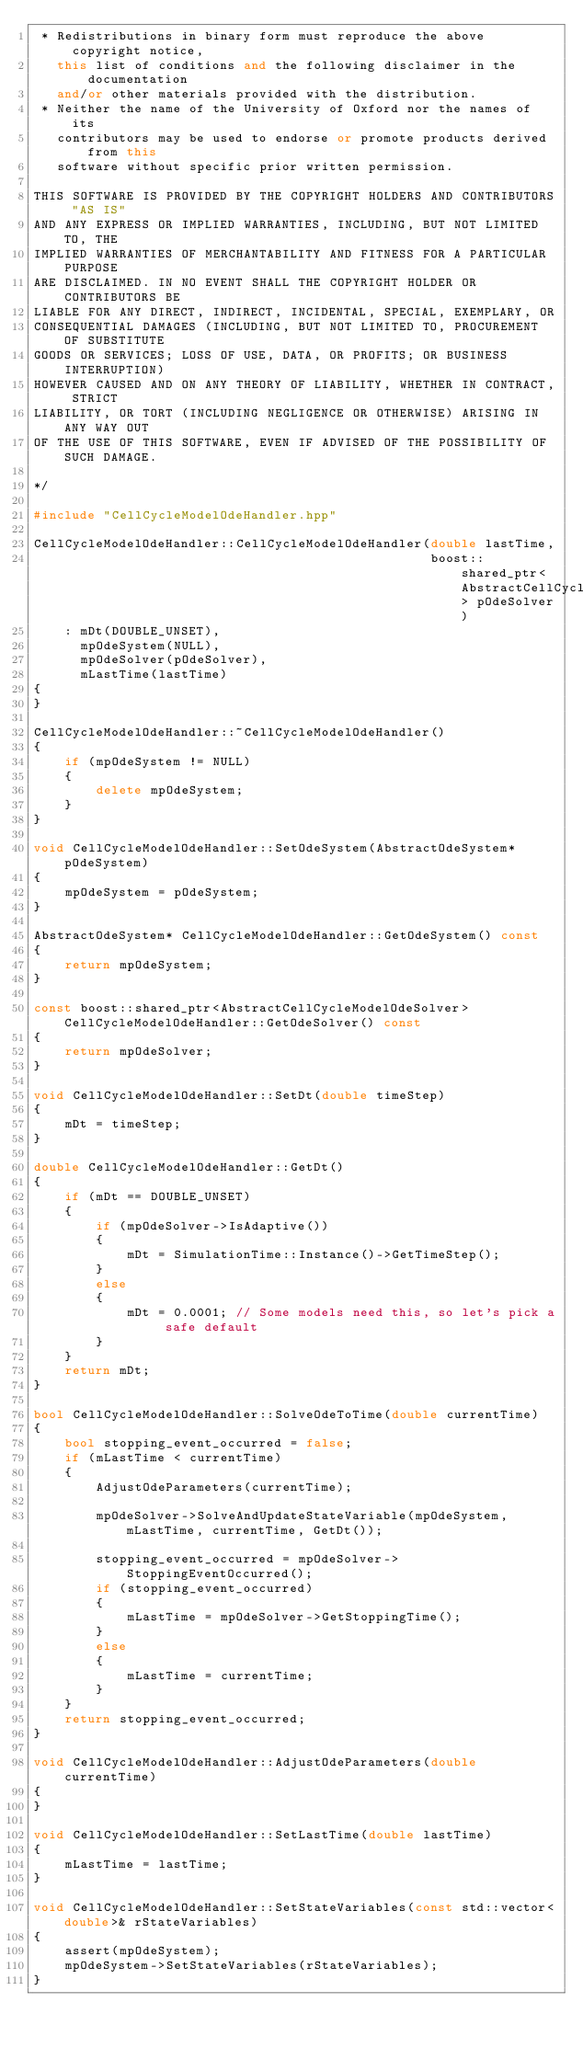<code> <loc_0><loc_0><loc_500><loc_500><_C++_> * Redistributions in binary form must reproduce the above copyright notice,
   this list of conditions and the following disclaimer in the documentation
   and/or other materials provided with the distribution.
 * Neither the name of the University of Oxford nor the names of its
   contributors may be used to endorse or promote products derived from this
   software without specific prior written permission.

THIS SOFTWARE IS PROVIDED BY THE COPYRIGHT HOLDERS AND CONTRIBUTORS "AS IS"
AND ANY EXPRESS OR IMPLIED WARRANTIES, INCLUDING, BUT NOT LIMITED TO, THE
IMPLIED WARRANTIES OF MERCHANTABILITY AND FITNESS FOR A PARTICULAR PURPOSE
ARE DISCLAIMED. IN NO EVENT SHALL THE COPYRIGHT HOLDER OR CONTRIBUTORS BE
LIABLE FOR ANY DIRECT, INDIRECT, INCIDENTAL, SPECIAL, EXEMPLARY, OR
CONSEQUENTIAL DAMAGES (INCLUDING, BUT NOT LIMITED TO, PROCUREMENT OF SUBSTITUTE
GOODS OR SERVICES; LOSS OF USE, DATA, OR PROFITS; OR BUSINESS INTERRUPTION)
HOWEVER CAUSED AND ON ANY THEORY OF LIABILITY, WHETHER IN CONTRACT, STRICT
LIABILITY, OR TORT (INCLUDING NEGLIGENCE OR OTHERWISE) ARISING IN ANY WAY OUT
OF THE USE OF THIS SOFTWARE, EVEN IF ADVISED OF THE POSSIBILITY OF SUCH DAMAGE.

*/

#include "CellCycleModelOdeHandler.hpp"

CellCycleModelOdeHandler::CellCycleModelOdeHandler(double lastTime,
                                                   boost::shared_ptr<AbstractCellCycleModelOdeSolver> pOdeSolver)
    : mDt(DOUBLE_UNSET),
      mpOdeSystem(NULL),
      mpOdeSolver(pOdeSolver),
      mLastTime(lastTime)
{
}

CellCycleModelOdeHandler::~CellCycleModelOdeHandler()
{
    if (mpOdeSystem != NULL)
    {
        delete mpOdeSystem;
    }
}

void CellCycleModelOdeHandler::SetOdeSystem(AbstractOdeSystem* pOdeSystem)
{
    mpOdeSystem = pOdeSystem;
}

AbstractOdeSystem* CellCycleModelOdeHandler::GetOdeSystem() const
{
    return mpOdeSystem;
}

const boost::shared_ptr<AbstractCellCycleModelOdeSolver> CellCycleModelOdeHandler::GetOdeSolver() const
{
    return mpOdeSolver;
}

void CellCycleModelOdeHandler::SetDt(double timeStep)
{
    mDt = timeStep;
}

double CellCycleModelOdeHandler::GetDt()
{
    if (mDt == DOUBLE_UNSET)
    {
        if (mpOdeSolver->IsAdaptive())
        {
            mDt = SimulationTime::Instance()->GetTimeStep();
        }
        else
        {
            mDt = 0.0001; // Some models need this, so let's pick a safe default
        }
    }
    return mDt;
}

bool CellCycleModelOdeHandler::SolveOdeToTime(double currentTime)
{
    bool stopping_event_occurred = false;
    if (mLastTime < currentTime)
    {
        AdjustOdeParameters(currentTime);

        mpOdeSolver->SolveAndUpdateStateVariable(mpOdeSystem, mLastTime, currentTime, GetDt());

        stopping_event_occurred = mpOdeSolver->StoppingEventOccurred();
        if (stopping_event_occurred)
        {
            mLastTime = mpOdeSolver->GetStoppingTime();
        }
        else
        {
            mLastTime = currentTime;
        }
    }
    return stopping_event_occurred;
}

void CellCycleModelOdeHandler::AdjustOdeParameters(double currentTime)
{
}

void CellCycleModelOdeHandler::SetLastTime(double lastTime)
{
    mLastTime = lastTime;
}

void CellCycleModelOdeHandler::SetStateVariables(const std::vector<double>& rStateVariables)
{
    assert(mpOdeSystem);
    mpOdeSystem->SetStateVariables(rStateVariables);
}
</code> 